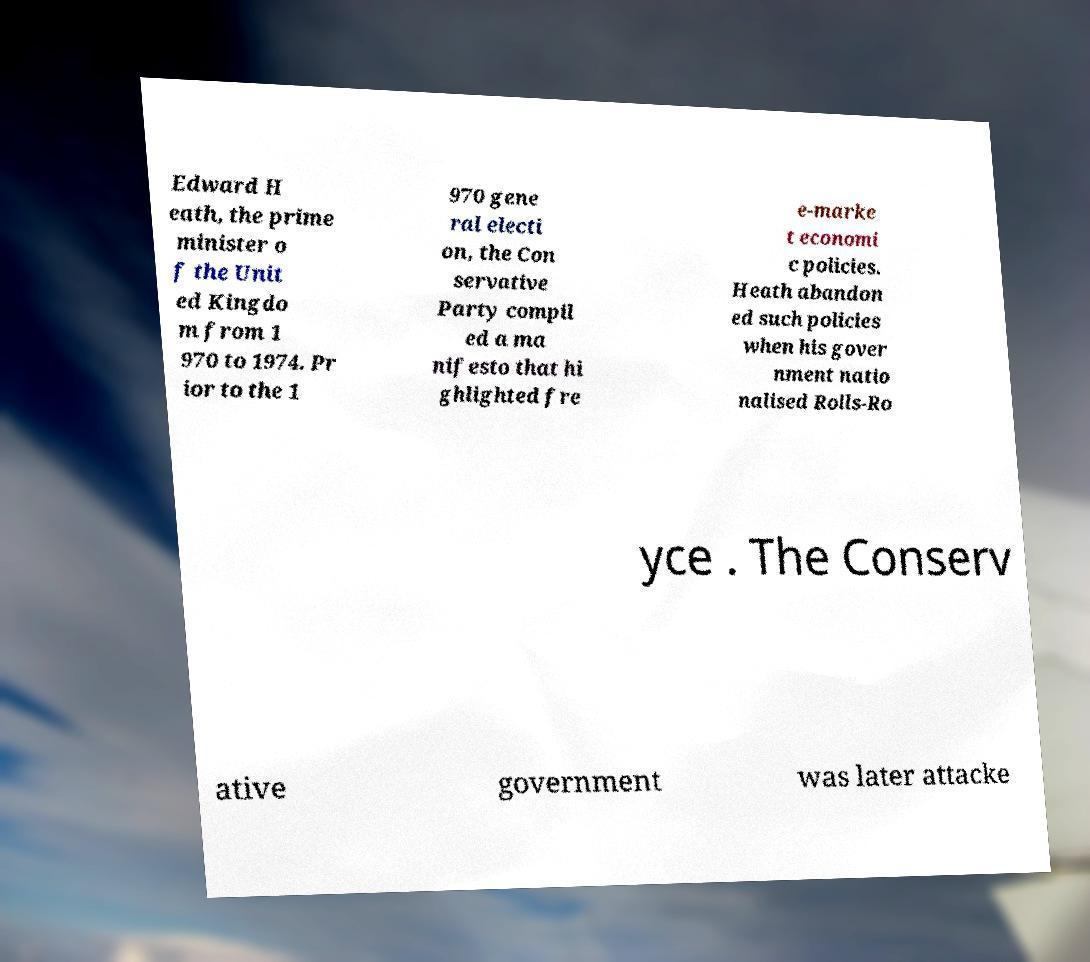Please read and relay the text visible in this image. What does it say? Edward H eath, the prime minister o f the Unit ed Kingdo m from 1 970 to 1974. Pr ior to the 1 970 gene ral electi on, the Con servative Party compil ed a ma nifesto that hi ghlighted fre e-marke t economi c policies. Heath abandon ed such policies when his gover nment natio nalised Rolls-Ro yce . The Conserv ative government was later attacke 